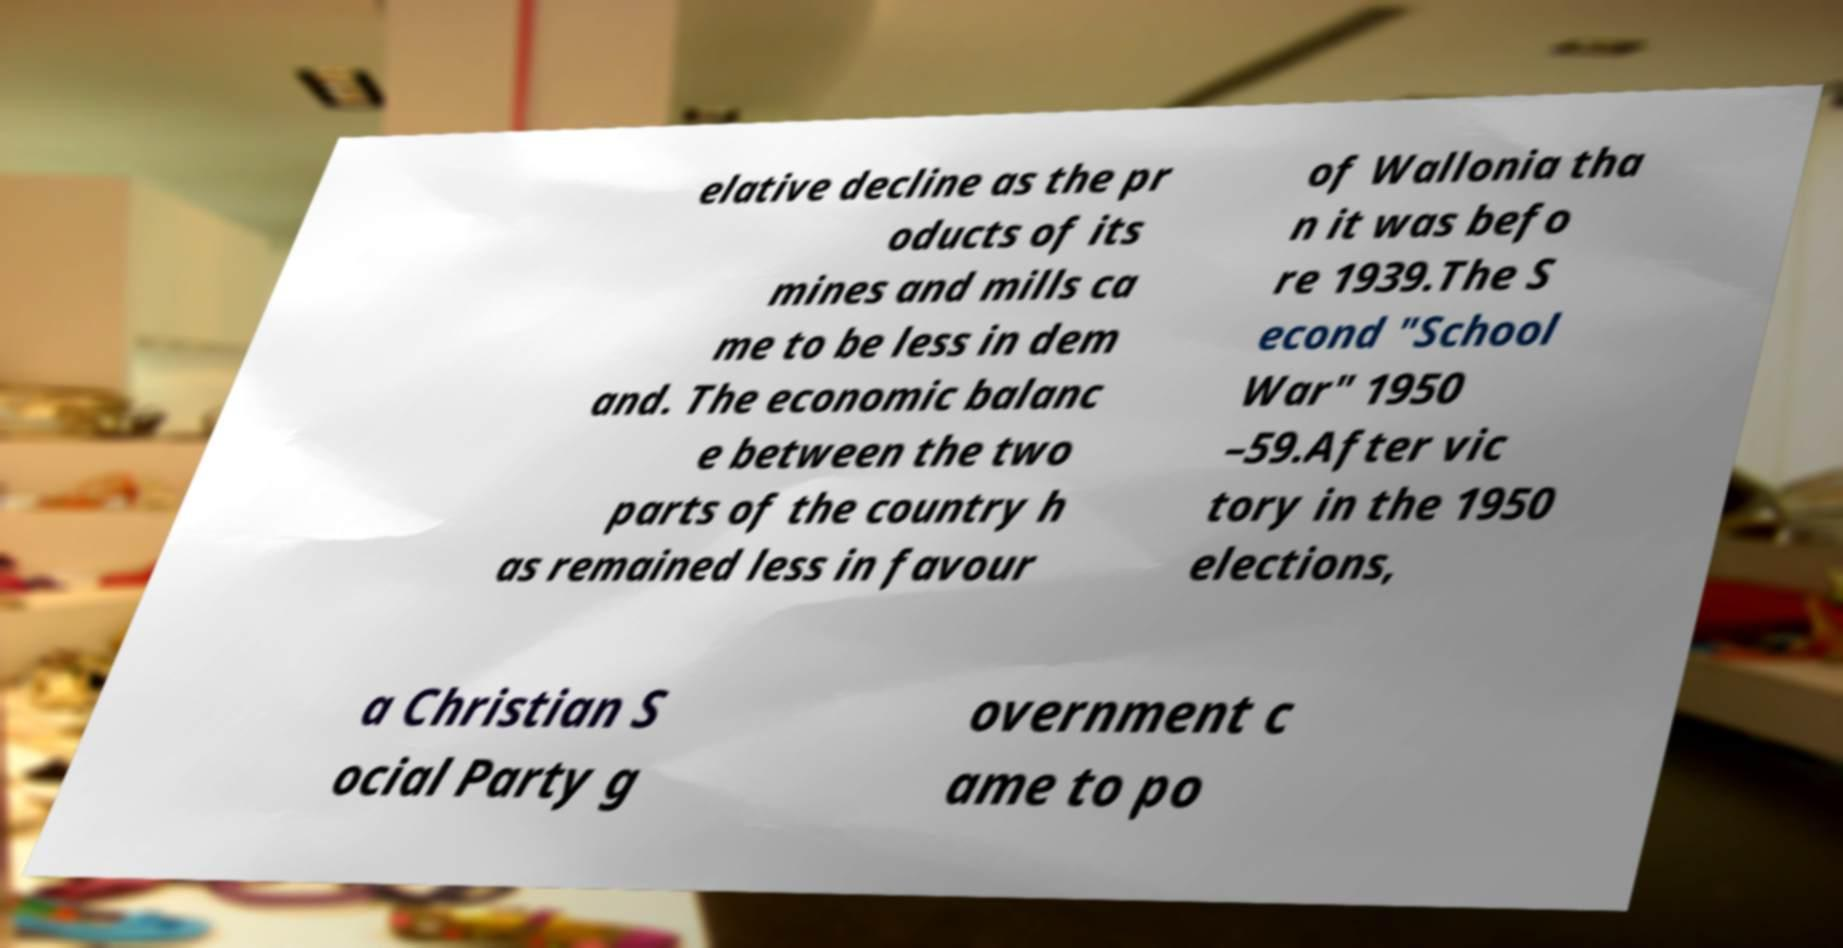Could you assist in decoding the text presented in this image and type it out clearly? elative decline as the pr oducts of its mines and mills ca me to be less in dem and. The economic balanc e between the two parts of the country h as remained less in favour of Wallonia tha n it was befo re 1939.The S econd "School War" 1950 –59.After vic tory in the 1950 elections, a Christian S ocial Party g overnment c ame to po 